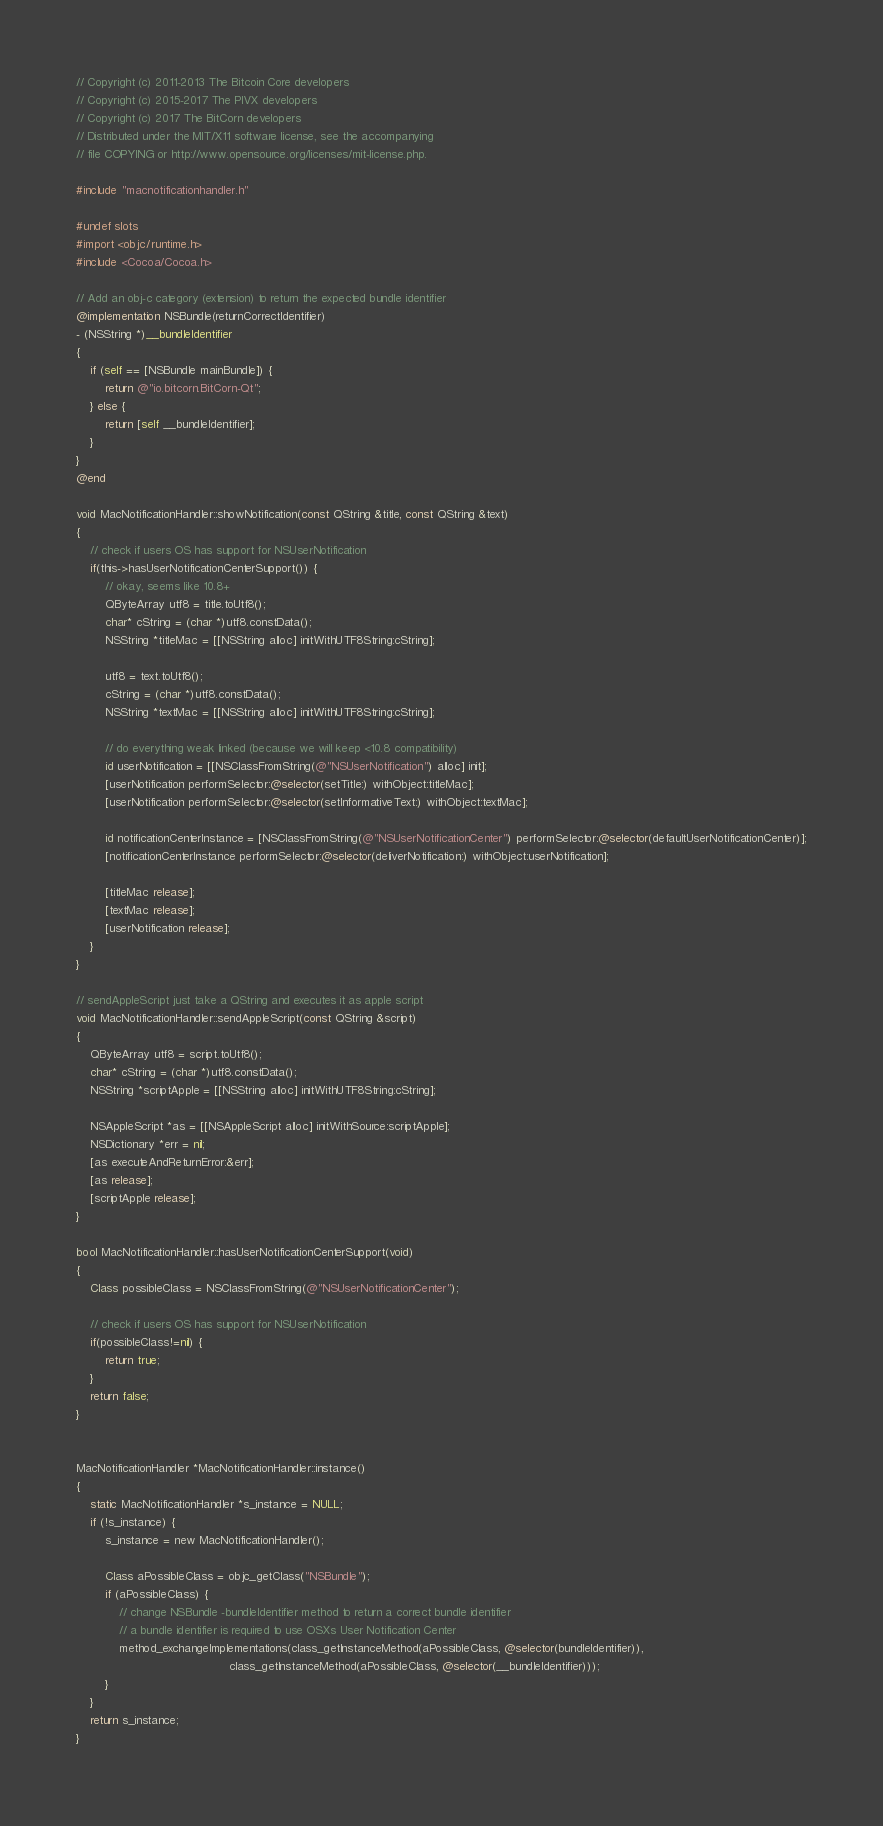Convert code to text. <code><loc_0><loc_0><loc_500><loc_500><_ObjectiveC_>// Copyright (c) 2011-2013 The Bitcoin Core developers
// Copyright (c) 2015-2017 The PIVX developers
// Copyright (c) 2017 The BitCorn developers
// Distributed under the MIT/X11 software license, see the accompanying
// file COPYING or http://www.opensource.org/licenses/mit-license.php.

#include "macnotificationhandler.h"

#undef slots
#import <objc/runtime.h>
#include <Cocoa/Cocoa.h>

// Add an obj-c category (extension) to return the expected bundle identifier
@implementation NSBundle(returnCorrectIdentifier)
- (NSString *)__bundleIdentifier
{
    if (self == [NSBundle mainBundle]) {
        return @"io.bitcorn.BitCorn-Qt";
    } else {
        return [self __bundleIdentifier];
    }
}
@end

void MacNotificationHandler::showNotification(const QString &title, const QString &text)
{
    // check if users OS has support for NSUserNotification
    if(this->hasUserNotificationCenterSupport()) {
        // okay, seems like 10.8+
        QByteArray utf8 = title.toUtf8();
        char* cString = (char *)utf8.constData();
        NSString *titleMac = [[NSString alloc] initWithUTF8String:cString];

        utf8 = text.toUtf8();
        cString = (char *)utf8.constData();
        NSString *textMac = [[NSString alloc] initWithUTF8String:cString];

        // do everything weak linked (because we will keep <10.8 compatibility)
        id userNotification = [[NSClassFromString(@"NSUserNotification") alloc] init];
        [userNotification performSelector:@selector(setTitle:) withObject:titleMac];
        [userNotification performSelector:@selector(setInformativeText:) withObject:textMac];

        id notificationCenterInstance = [NSClassFromString(@"NSUserNotificationCenter") performSelector:@selector(defaultUserNotificationCenter)];
        [notificationCenterInstance performSelector:@selector(deliverNotification:) withObject:userNotification];

        [titleMac release];
        [textMac release];
        [userNotification release];
    }
}

// sendAppleScript just take a QString and executes it as apple script
void MacNotificationHandler::sendAppleScript(const QString &script)
{
    QByteArray utf8 = script.toUtf8();
    char* cString = (char *)utf8.constData();
    NSString *scriptApple = [[NSString alloc] initWithUTF8String:cString];

    NSAppleScript *as = [[NSAppleScript alloc] initWithSource:scriptApple];
    NSDictionary *err = nil;
    [as executeAndReturnError:&err];
    [as release];
    [scriptApple release];
}

bool MacNotificationHandler::hasUserNotificationCenterSupport(void)
{
    Class possibleClass = NSClassFromString(@"NSUserNotificationCenter");

    // check if users OS has support for NSUserNotification
    if(possibleClass!=nil) {
        return true;
    }
    return false;
}


MacNotificationHandler *MacNotificationHandler::instance()
{
    static MacNotificationHandler *s_instance = NULL;
    if (!s_instance) {
        s_instance = new MacNotificationHandler();
        
        Class aPossibleClass = objc_getClass("NSBundle");
        if (aPossibleClass) {
            // change NSBundle -bundleIdentifier method to return a correct bundle identifier
            // a bundle identifier is required to use OSXs User Notification Center
            method_exchangeImplementations(class_getInstanceMethod(aPossibleClass, @selector(bundleIdentifier)),
                                           class_getInstanceMethod(aPossibleClass, @selector(__bundleIdentifier)));
        }
    }
    return s_instance;
}
</code> 